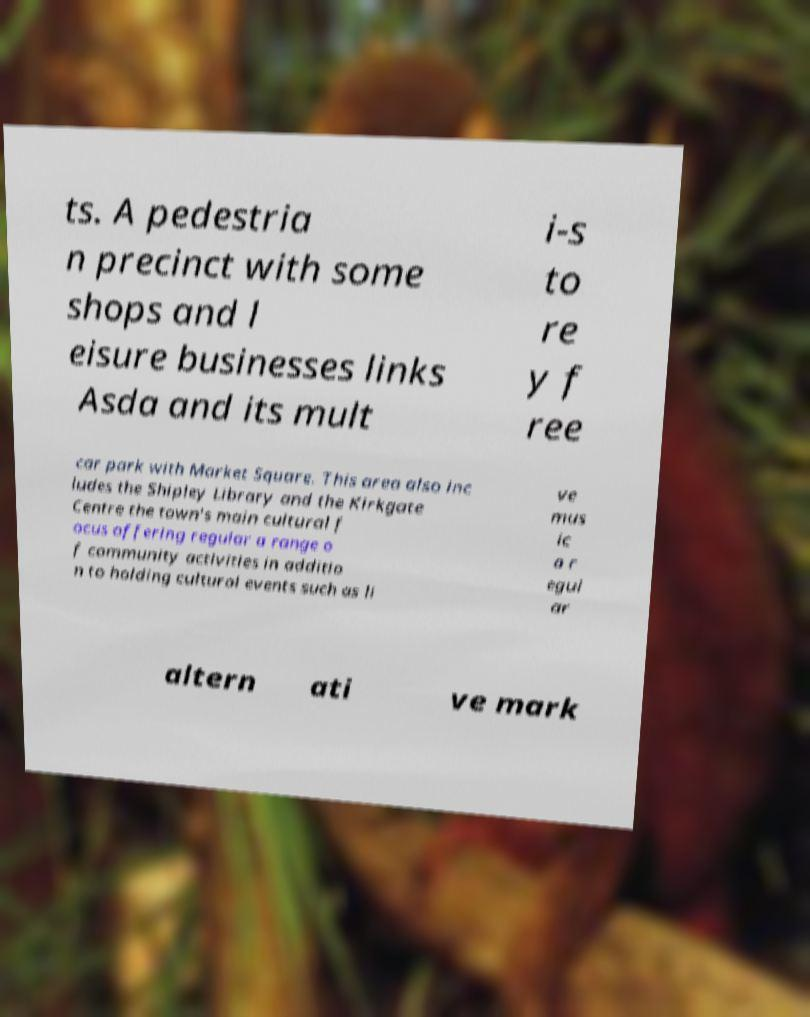What messages or text are displayed in this image? I need them in a readable, typed format. ts. A pedestria n precinct with some shops and l eisure businesses links Asda and its mult i-s to re y f ree car park with Market Square. This area also inc ludes the Shipley Library and the Kirkgate Centre the town's main cultural f ocus offering regular a range o f community activities in additio n to holding cultural events such as li ve mus ic a r egul ar altern ati ve mark 